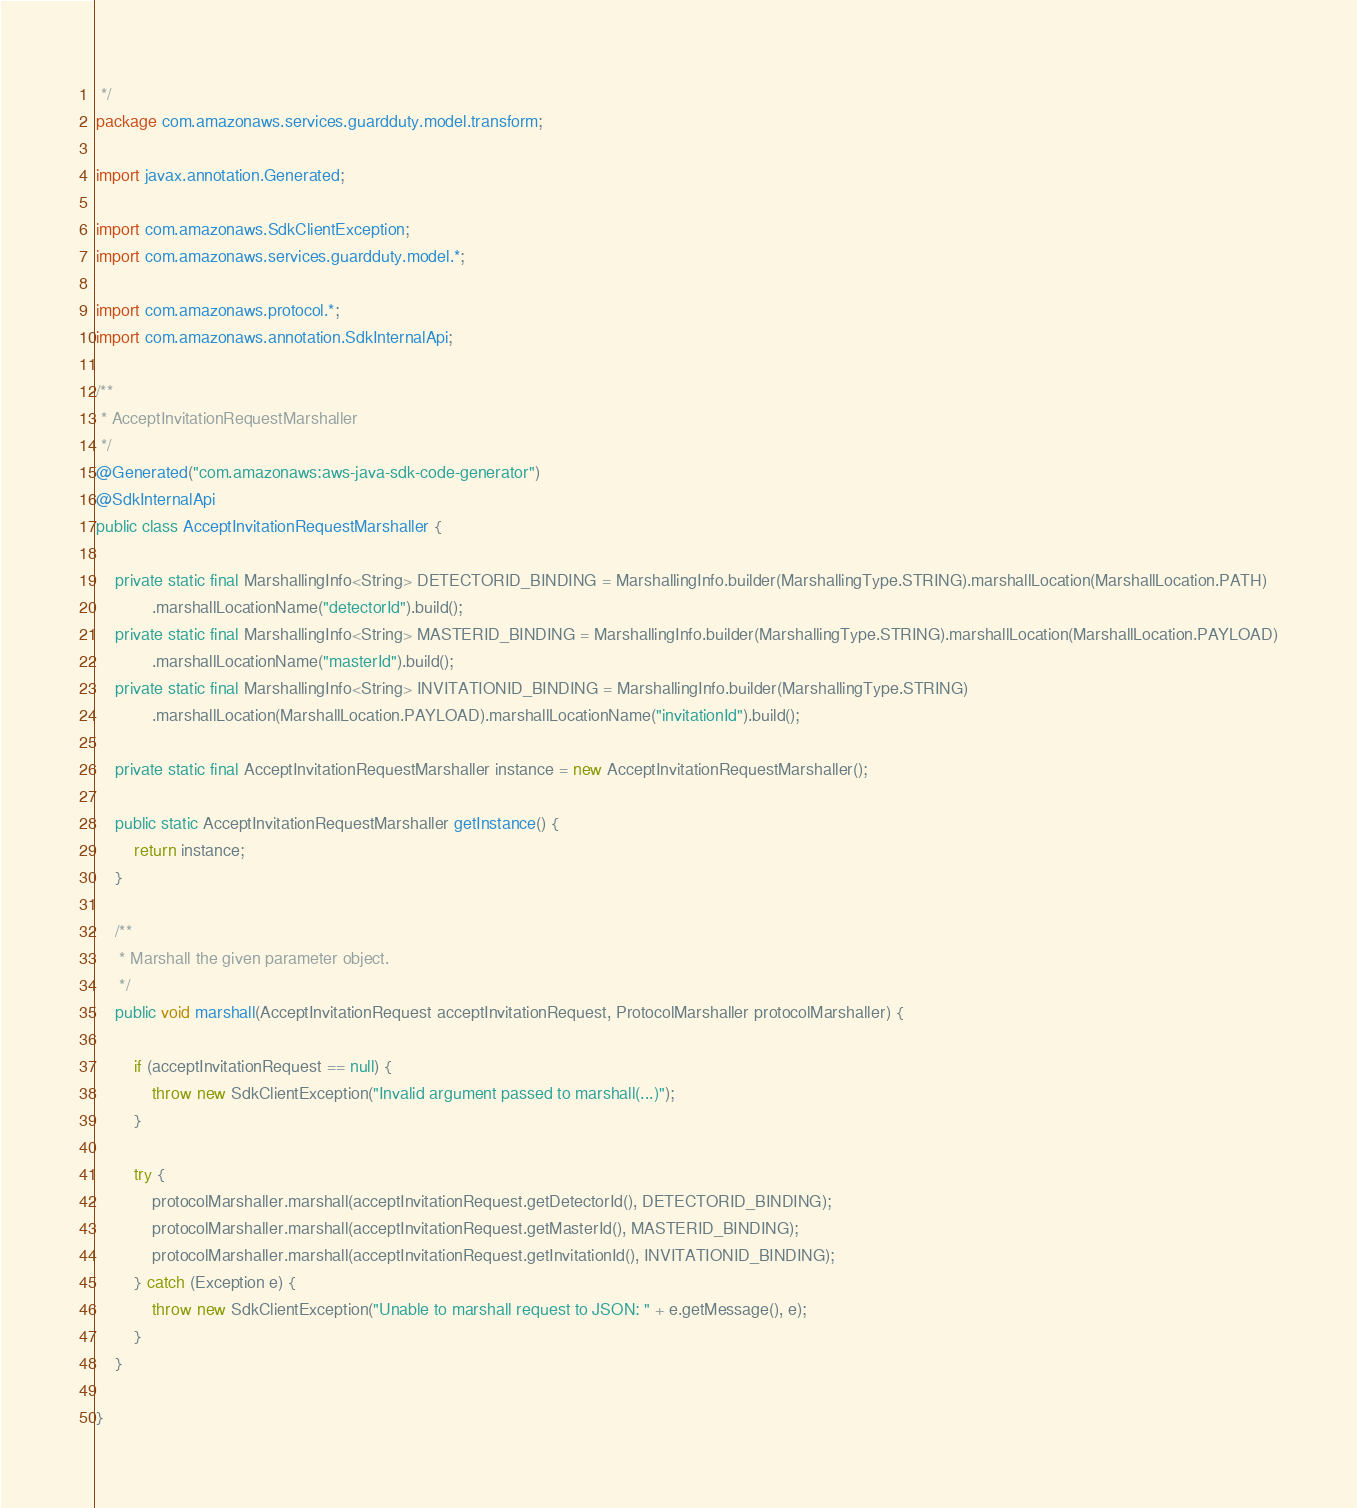Convert code to text. <code><loc_0><loc_0><loc_500><loc_500><_Java_> */
package com.amazonaws.services.guardduty.model.transform;

import javax.annotation.Generated;

import com.amazonaws.SdkClientException;
import com.amazonaws.services.guardduty.model.*;

import com.amazonaws.protocol.*;
import com.amazonaws.annotation.SdkInternalApi;

/**
 * AcceptInvitationRequestMarshaller
 */
@Generated("com.amazonaws:aws-java-sdk-code-generator")
@SdkInternalApi
public class AcceptInvitationRequestMarshaller {

    private static final MarshallingInfo<String> DETECTORID_BINDING = MarshallingInfo.builder(MarshallingType.STRING).marshallLocation(MarshallLocation.PATH)
            .marshallLocationName("detectorId").build();
    private static final MarshallingInfo<String> MASTERID_BINDING = MarshallingInfo.builder(MarshallingType.STRING).marshallLocation(MarshallLocation.PAYLOAD)
            .marshallLocationName("masterId").build();
    private static final MarshallingInfo<String> INVITATIONID_BINDING = MarshallingInfo.builder(MarshallingType.STRING)
            .marshallLocation(MarshallLocation.PAYLOAD).marshallLocationName("invitationId").build();

    private static final AcceptInvitationRequestMarshaller instance = new AcceptInvitationRequestMarshaller();

    public static AcceptInvitationRequestMarshaller getInstance() {
        return instance;
    }

    /**
     * Marshall the given parameter object.
     */
    public void marshall(AcceptInvitationRequest acceptInvitationRequest, ProtocolMarshaller protocolMarshaller) {

        if (acceptInvitationRequest == null) {
            throw new SdkClientException("Invalid argument passed to marshall(...)");
        }

        try {
            protocolMarshaller.marshall(acceptInvitationRequest.getDetectorId(), DETECTORID_BINDING);
            protocolMarshaller.marshall(acceptInvitationRequest.getMasterId(), MASTERID_BINDING);
            protocolMarshaller.marshall(acceptInvitationRequest.getInvitationId(), INVITATIONID_BINDING);
        } catch (Exception e) {
            throw new SdkClientException("Unable to marshall request to JSON: " + e.getMessage(), e);
        }
    }

}
</code> 